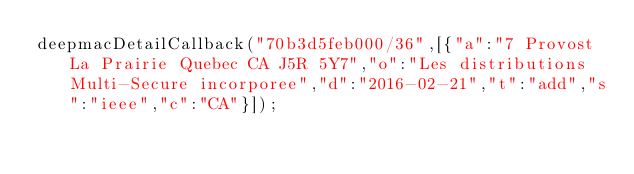<code> <loc_0><loc_0><loc_500><loc_500><_JavaScript_>deepmacDetailCallback("70b3d5feb000/36",[{"a":"7 Provost La Prairie Quebec CA J5R 5Y7","o":"Les distributions Multi-Secure incorporee","d":"2016-02-21","t":"add","s":"ieee","c":"CA"}]);
</code> 